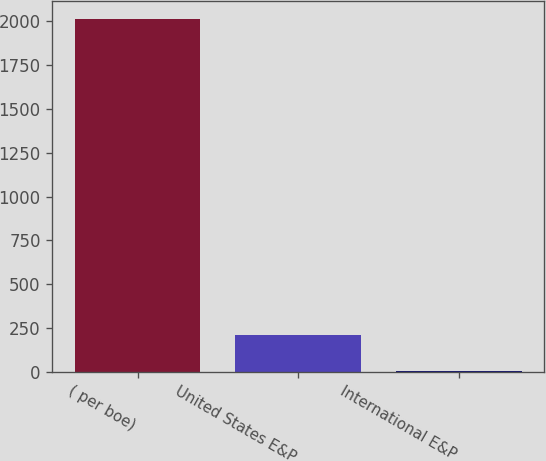<chart> <loc_0><loc_0><loc_500><loc_500><bar_chart><fcel>( per boe)<fcel>United States E&P<fcel>International E&P<nl><fcel>2016<fcel>207.19<fcel>6.21<nl></chart> 